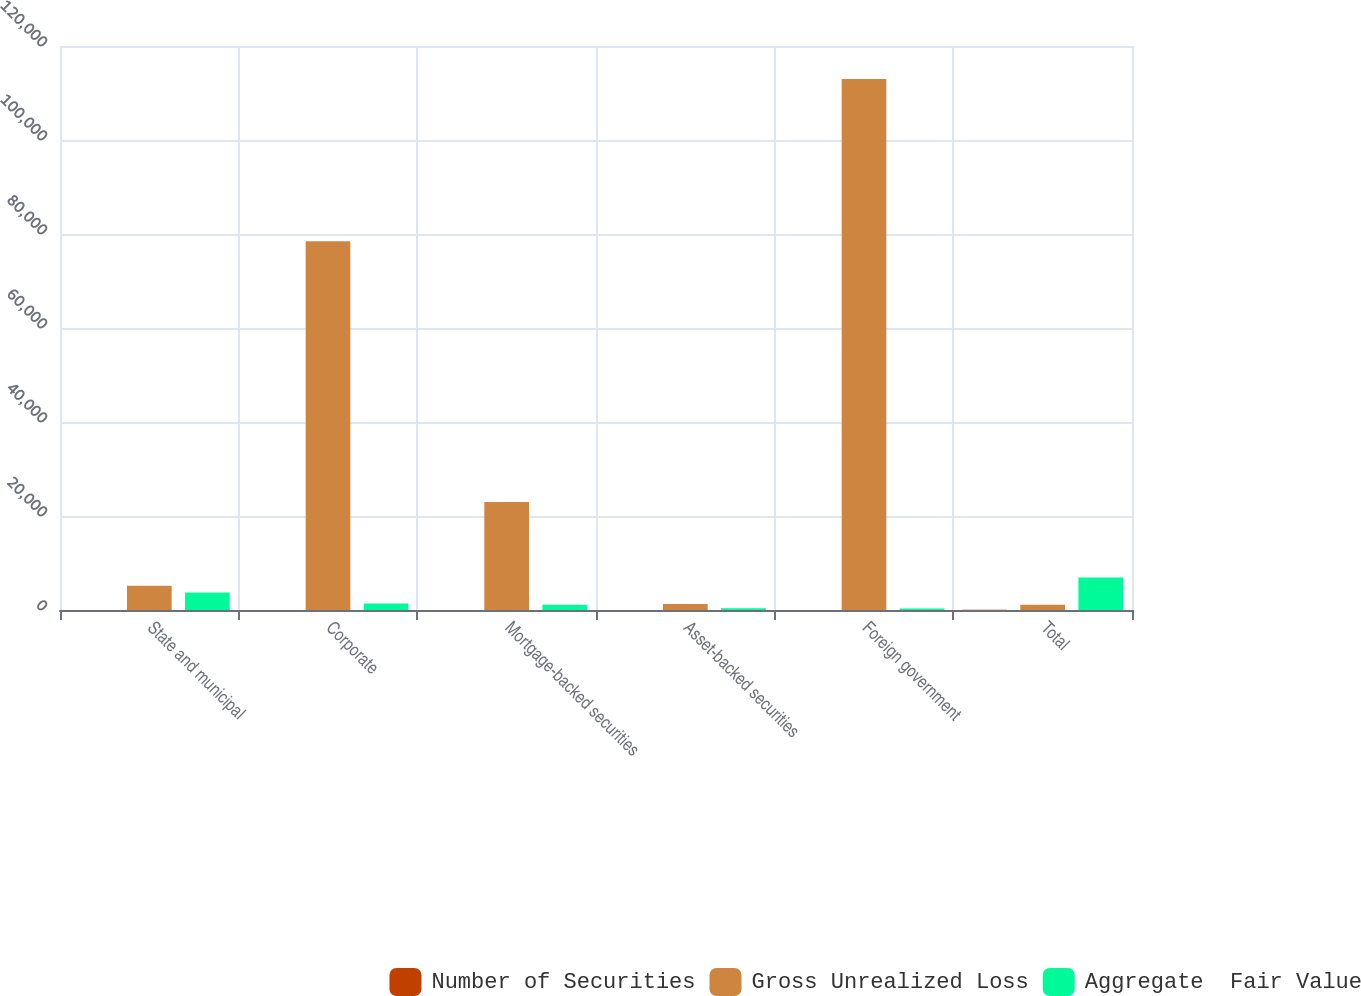Convert chart. <chart><loc_0><loc_0><loc_500><loc_500><stacked_bar_chart><ecel><fcel>State and municipal<fcel>Corporate<fcel>Mortgage-backed securities<fcel>Asset-backed securities<fcel>Foreign government<fcel>Total<nl><fcel>Number of Securities<fcel>1<fcel>10<fcel>11<fcel>4<fcel>15<fcel>41<nl><fcel>Gross Unrealized Loss<fcel>5136<fcel>78462<fcel>22987<fcel>1256<fcel>112985<fcel>1106<nl><fcel>Aggregate  Fair Value<fcel>3725<fcel>1370<fcel>1106<fcel>362<fcel>341<fcel>6904<nl></chart> 